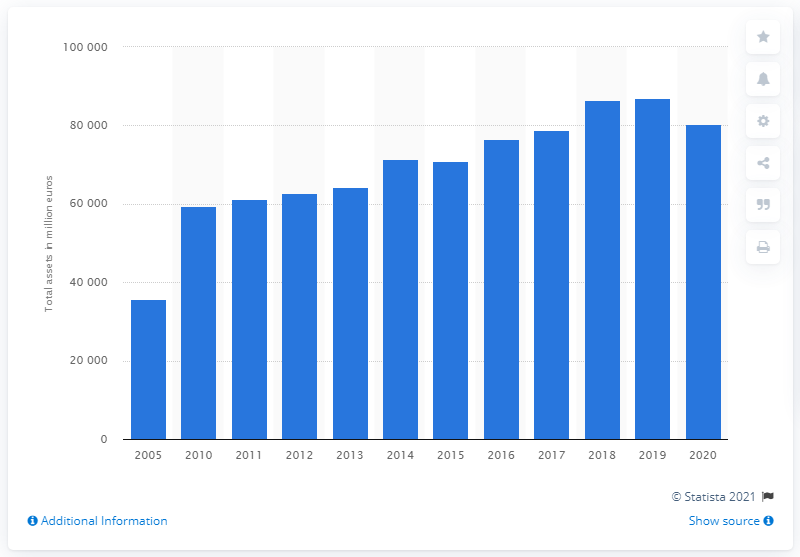Indicate a few pertinent items in this graphic. In 2020, BASF's total assets were 80,292. 